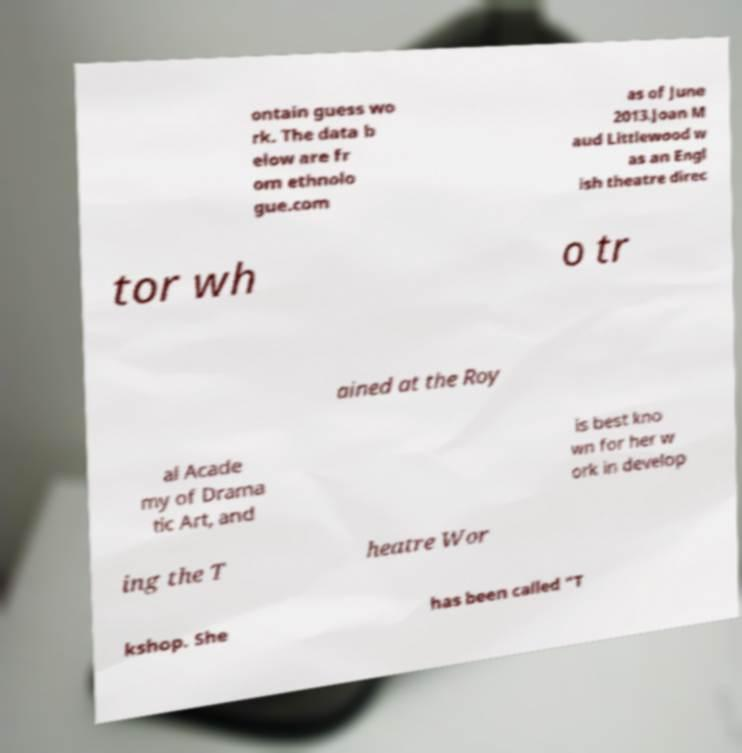Could you assist in decoding the text presented in this image and type it out clearly? ontain guess wo rk. The data b elow are fr om ethnolo gue.com as of June 2013.Joan M aud Littlewood w as an Engl ish theatre direc tor wh o tr ained at the Roy al Acade my of Drama tic Art, and is best kno wn for her w ork in develop ing the T heatre Wor kshop. She has been called "T 